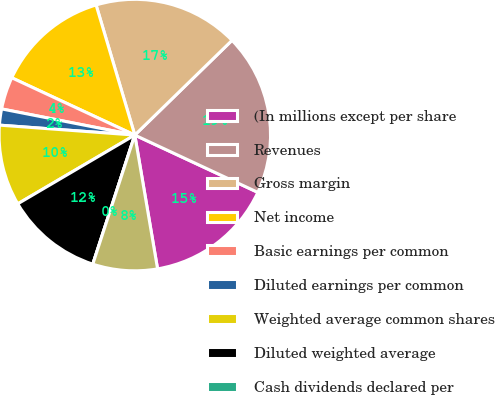Convert chart to OTSL. <chart><loc_0><loc_0><loc_500><loc_500><pie_chart><fcel>(In millions except per share<fcel>Revenues<fcel>Gross margin<fcel>Net income<fcel>Basic earnings per common<fcel>Diluted earnings per common<fcel>Weighted average common shares<fcel>Diluted weighted average<fcel>Cash dividends declared per<fcel>High<nl><fcel>15.38%<fcel>19.23%<fcel>17.31%<fcel>13.46%<fcel>3.85%<fcel>1.92%<fcel>9.62%<fcel>11.54%<fcel>0.0%<fcel>7.69%<nl></chart> 